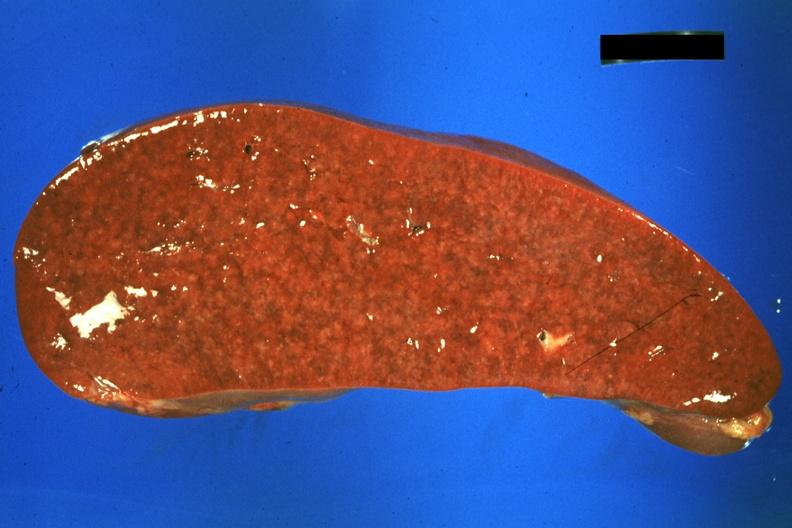s spleen present?
Answer the question using a single word or phrase. Yes 